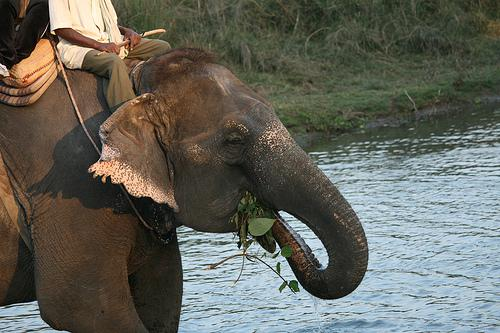Question: what is it doing?
Choices:
A. Playing.
B. Running.
C. Looking at the camera.
D. Eating.
Answer with the letter. Answer: D Question: where is the elephant?
Choices:
A. In the field.
B. In the water.
C. At the zoo.
D. At the circus.
Answer with the letter. Answer: B Question: what is gray?
Choices:
A. The bus.
B. The train.
C. Elephant.
D. The woman's shirt.
Answer with the letter. Answer: C Question: when is it?
Choices:
A. Night time.
B. Day time.
C. Winter time.
D. Morning.
Answer with the letter. Answer: B Question: why are they there?
Choices:
A. To watch a baseball game.
B. To watch a football game.
C. Traveling.
D. To watch a tennis match.
Answer with the letter. Answer: C 